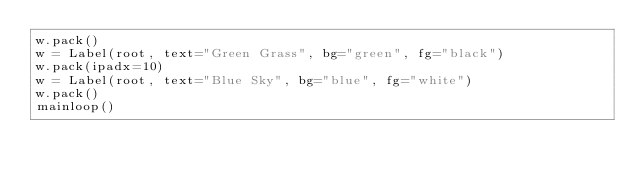<code> <loc_0><loc_0><loc_500><loc_500><_Python_>w.pack()
w = Label(root, text="Green Grass", bg="green", fg="black")
w.pack(ipadx=10)
w = Label(root, text="Blue Sky", bg="blue", fg="white")
w.pack()
mainloop()
</code> 